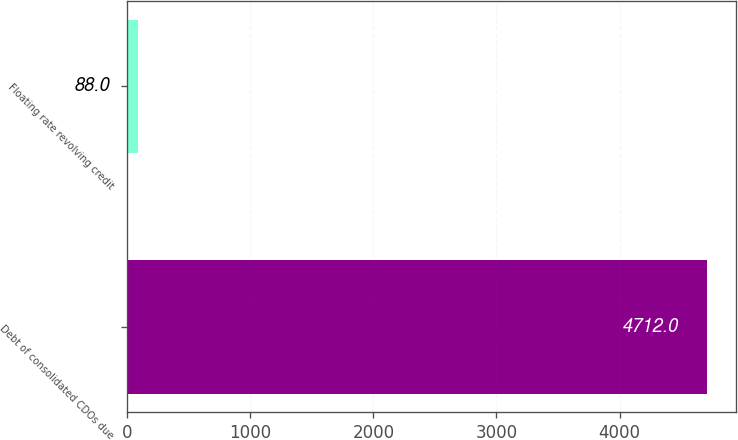<chart> <loc_0><loc_0><loc_500><loc_500><bar_chart><fcel>Debt of consolidated CDOs due<fcel>Floating rate revolving credit<nl><fcel>4712<fcel>88<nl></chart> 